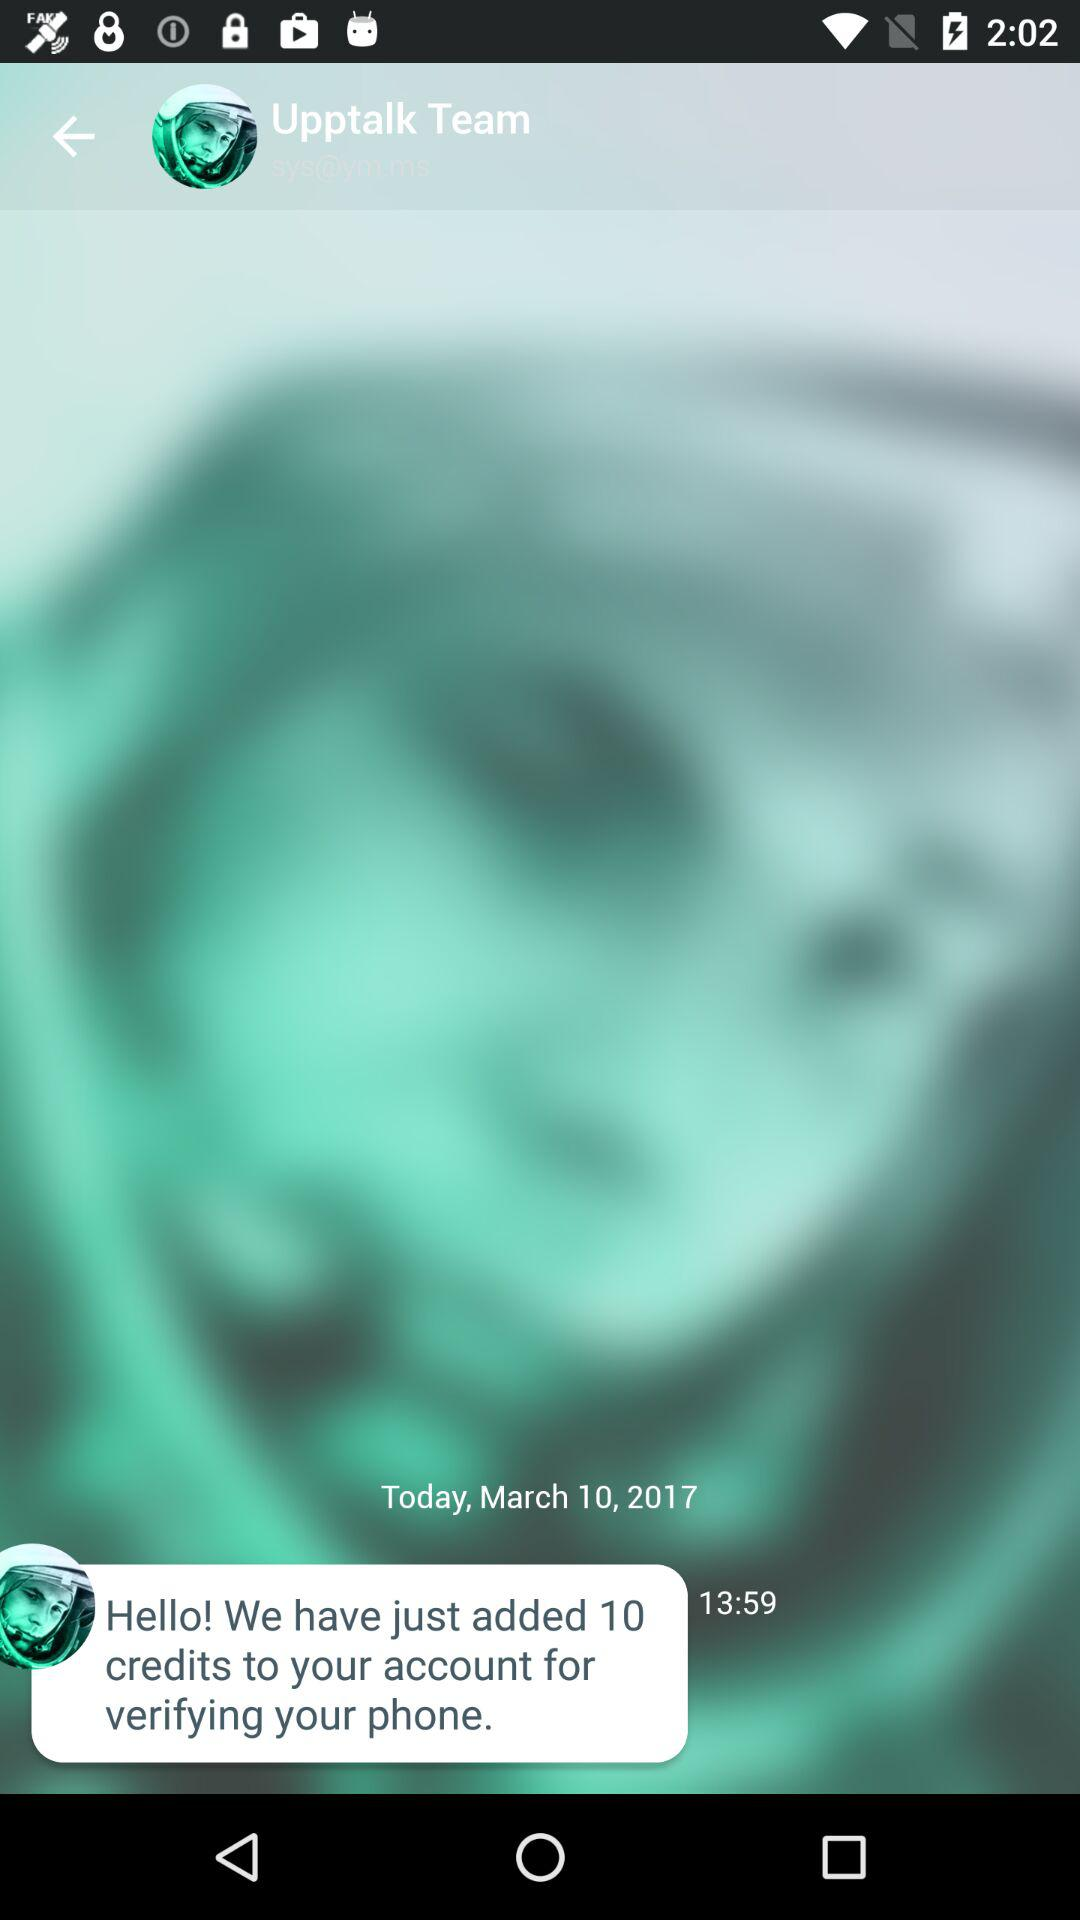How many credits have been added?
Answer the question using a single word or phrase. 10 